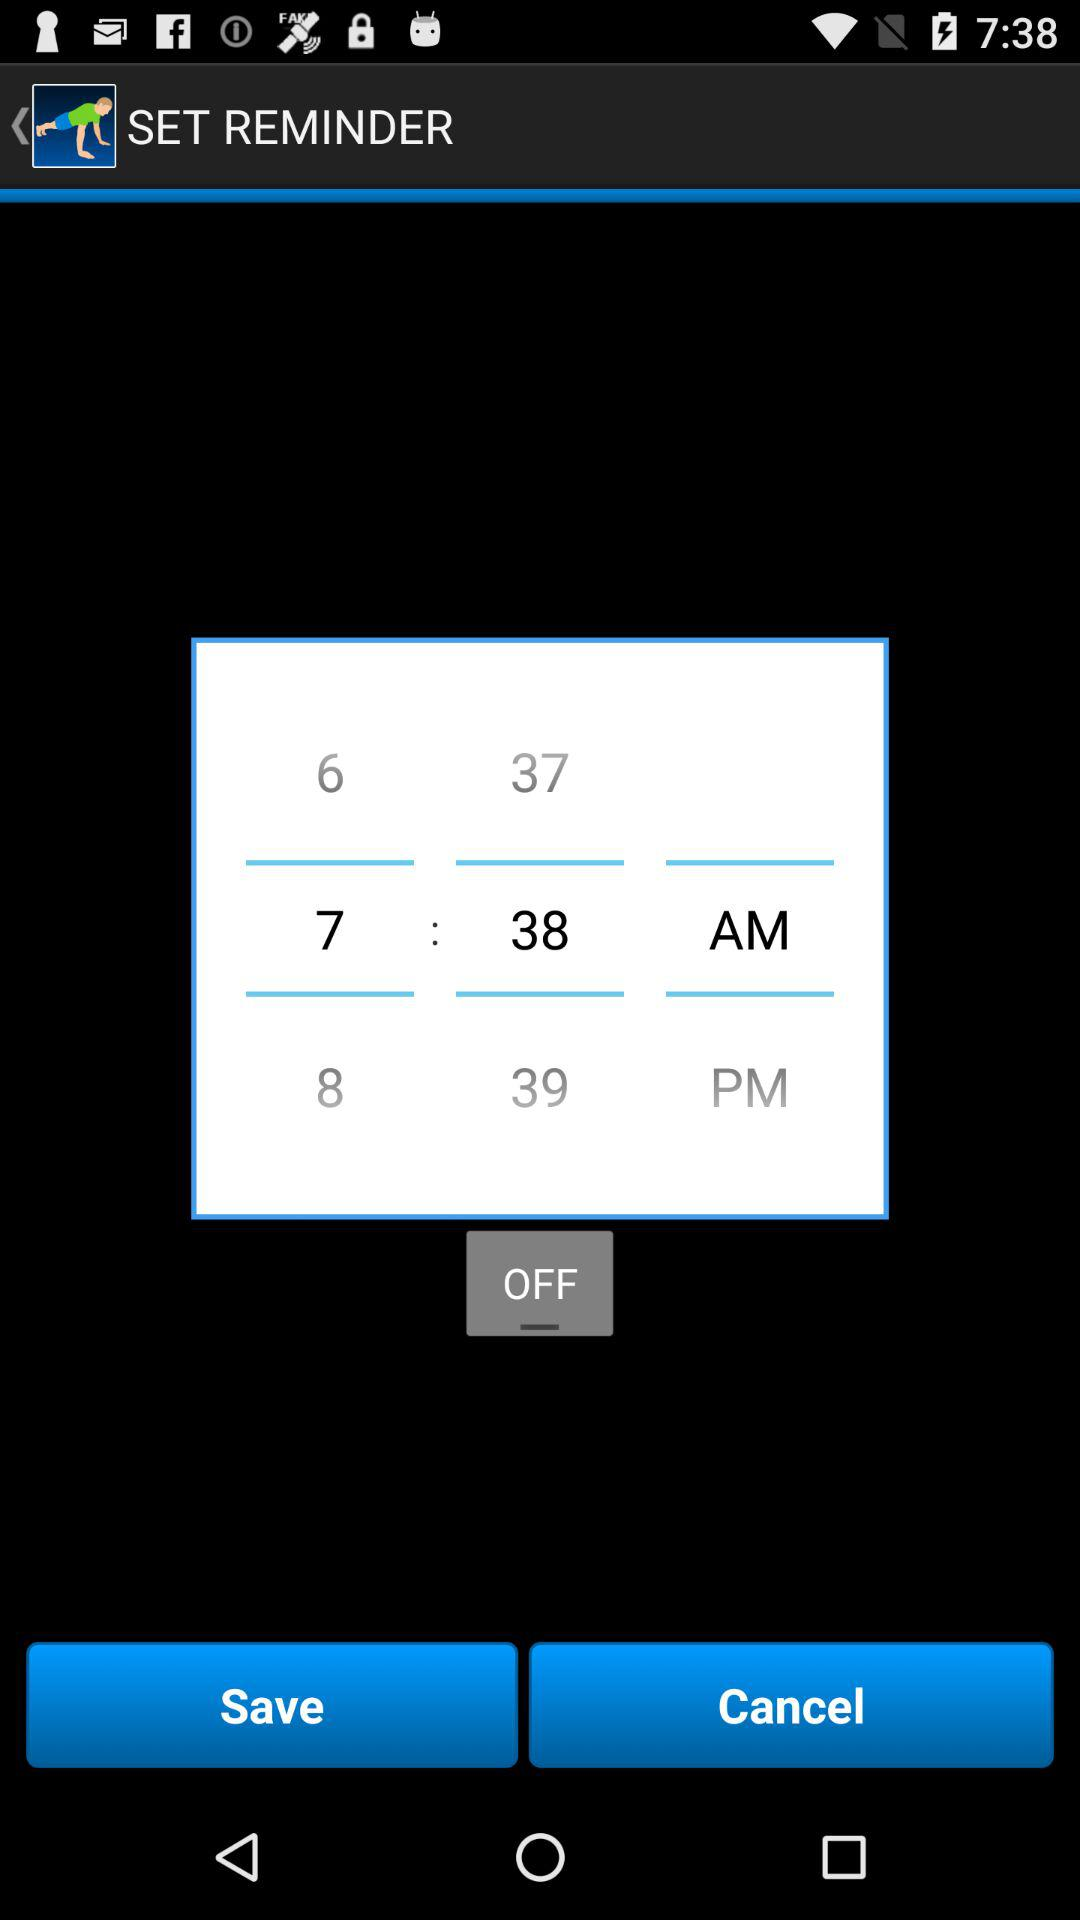What is the time set for the reminder? The time set for the reminder is 7:38 a.m. 